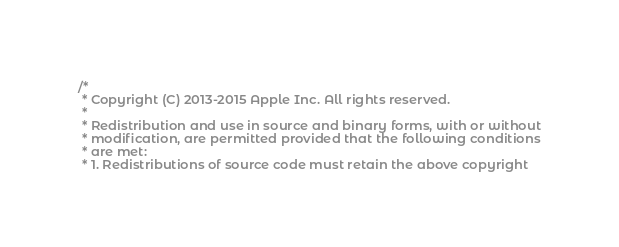<code> <loc_0><loc_0><loc_500><loc_500><_ObjectiveC_>/*
 * Copyright (C) 2013-2015 Apple Inc. All rights reserved.
 *
 * Redistribution and use in source and binary forms, with or without
 * modification, are permitted provided that the following conditions
 * are met:
 * 1. Redistributions of source code must retain the above copyright</code> 